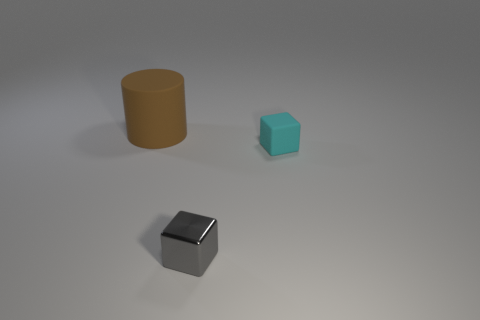Subtract all cyan cubes. Subtract all purple cylinders. How many cubes are left? 1 Add 3 large gray rubber cylinders. How many objects exist? 6 Subtract all blocks. How many objects are left? 1 Subtract 0 brown cubes. How many objects are left? 3 Subtract all brown matte cylinders. Subtract all brown cylinders. How many objects are left? 1 Add 1 cylinders. How many cylinders are left? 2 Add 3 purple metal cylinders. How many purple metal cylinders exist? 3 